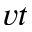Convert formula to latex. <formula><loc_0><loc_0><loc_500><loc_500>v t</formula> 